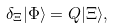Convert formula to latex. <formula><loc_0><loc_0><loc_500><loc_500>\delta _ { \Xi } | \Phi \rangle = Q | \Xi \rangle ,</formula> 